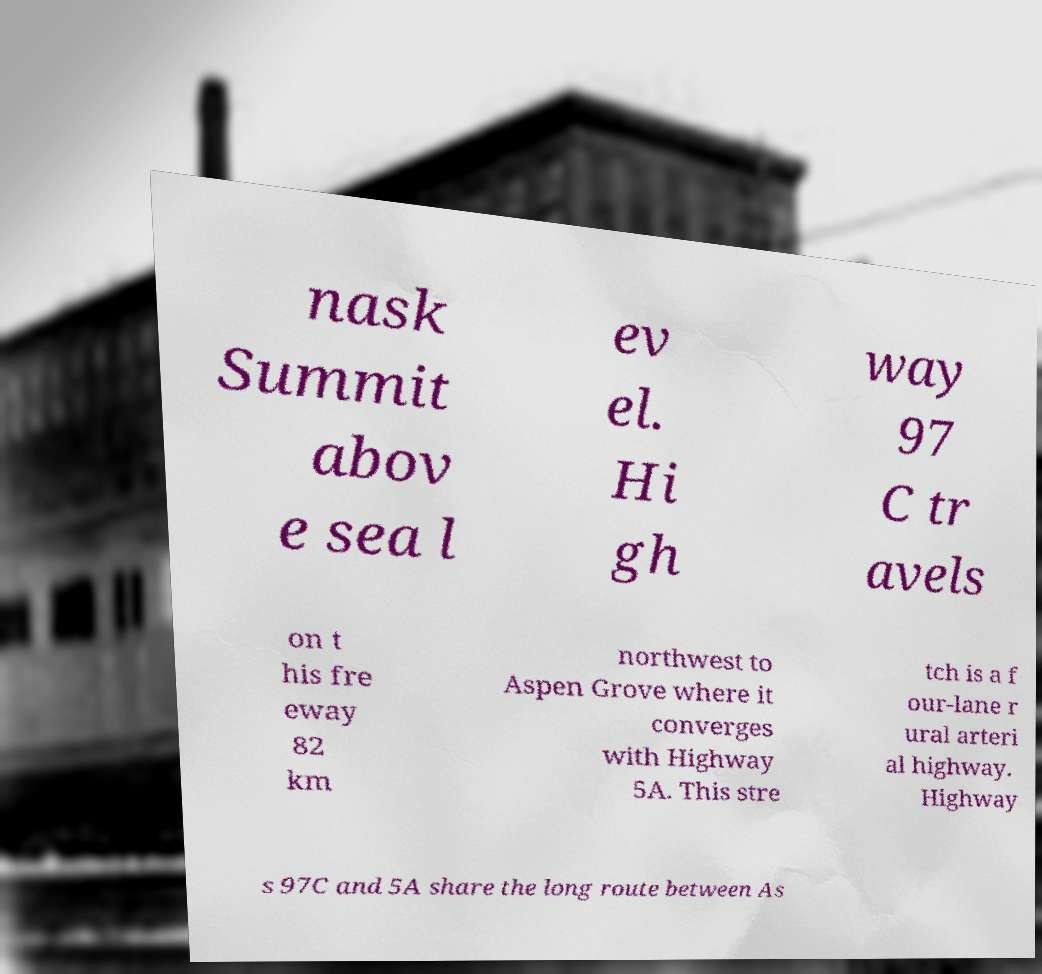Please read and relay the text visible in this image. What does it say? nask Summit abov e sea l ev el. Hi gh way 97 C tr avels on t his fre eway 82 km northwest to Aspen Grove where it converges with Highway 5A. This stre tch is a f our-lane r ural arteri al highway. Highway s 97C and 5A share the long route between As 